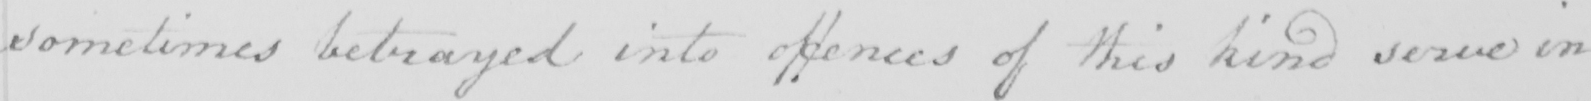Transcribe the text shown in this historical manuscript line. sometimes betrayed into offences of this kind serve in 